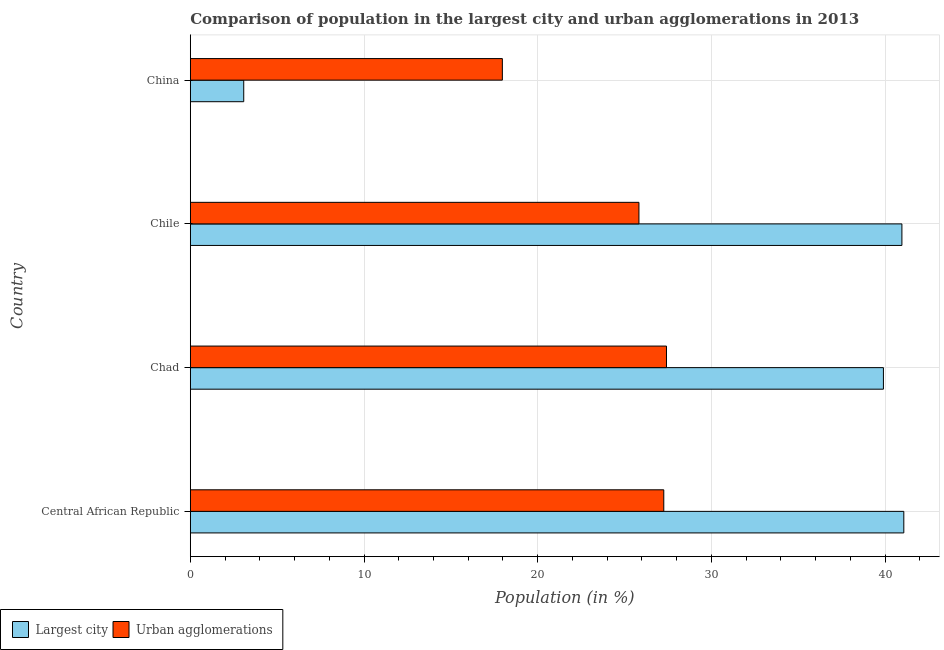Are the number of bars per tick equal to the number of legend labels?
Ensure brevity in your answer.  Yes. Are the number of bars on each tick of the Y-axis equal?
Your response must be concise. Yes. How many bars are there on the 2nd tick from the bottom?
Give a very brief answer. 2. What is the label of the 3rd group of bars from the top?
Make the answer very short. Chad. In how many cases, is the number of bars for a given country not equal to the number of legend labels?
Ensure brevity in your answer.  0. What is the population in urban agglomerations in Chile?
Offer a terse response. 25.83. Across all countries, what is the maximum population in urban agglomerations?
Your answer should be very brief. 27.41. Across all countries, what is the minimum population in the largest city?
Ensure brevity in your answer.  3.08. In which country was the population in urban agglomerations maximum?
Give a very brief answer. Chad. In which country was the population in the largest city minimum?
Ensure brevity in your answer.  China. What is the total population in urban agglomerations in the graph?
Ensure brevity in your answer.  98.46. What is the difference between the population in urban agglomerations in Central African Republic and that in Chad?
Ensure brevity in your answer.  -0.16. What is the difference between the population in urban agglomerations in China and the population in the largest city in Chile?
Ensure brevity in your answer.  -23. What is the average population in the largest city per country?
Provide a succinct answer. 31.25. What is the difference between the population in urban agglomerations and population in the largest city in Central African Republic?
Provide a short and direct response. -13.82. What is the ratio of the population in urban agglomerations in Central African Republic to that in China?
Give a very brief answer. 1.52. Is the population in urban agglomerations in Central African Republic less than that in China?
Provide a short and direct response. No. What is the difference between the highest and the second highest population in the largest city?
Provide a short and direct response. 0.11. In how many countries, is the population in urban agglomerations greater than the average population in urban agglomerations taken over all countries?
Ensure brevity in your answer.  3. What does the 1st bar from the top in Central African Republic represents?
Ensure brevity in your answer.  Urban agglomerations. What does the 2nd bar from the bottom in Chad represents?
Keep it short and to the point. Urban agglomerations. How many bars are there?
Give a very brief answer. 8. Are all the bars in the graph horizontal?
Ensure brevity in your answer.  Yes. Are the values on the major ticks of X-axis written in scientific E-notation?
Give a very brief answer. No. Does the graph contain any zero values?
Your answer should be very brief. No. Does the graph contain grids?
Provide a short and direct response. Yes. How many legend labels are there?
Ensure brevity in your answer.  2. How are the legend labels stacked?
Provide a short and direct response. Horizontal. What is the title of the graph?
Your answer should be compact. Comparison of population in the largest city and urban agglomerations in 2013. What is the label or title of the X-axis?
Your answer should be very brief. Population (in %). What is the label or title of the Y-axis?
Make the answer very short. Country. What is the Population (in %) in Largest city in Central African Republic?
Make the answer very short. 41.07. What is the Population (in %) in Urban agglomerations in Central African Republic?
Provide a short and direct response. 27.26. What is the Population (in %) in Largest city in Chad?
Offer a terse response. 39.9. What is the Population (in %) of Urban agglomerations in Chad?
Offer a terse response. 27.41. What is the Population (in %) of Largest city in Chile?
Make the answer very short. 40.97. What is the Population (in %) of Urban agglomerations in Chile?
Give a very brief answer. 25.83. What is the Population (in %) in Largest city in China?
Make the answer very short. 3.08. What is the Population (in %) in Urban agglomerations in China?
Your answer should be very brief. 17.96. Across all countries, what is the maximum Population (in %) of Largest city?
Make the answer very short. 41.07. Across all countries, what is the maximum Population (in %) in Urban agglomerations?
Give a very brief answer. 27.41. Across all countries, what is the minimum Population (in %) in Largest city?
Your answer should be very brief. 3.08. Across all countries, what is the minimum Population (in %) of Urban agglomerations?
Offer a very short reply. 17.96. What is the total Population (in %) of Largest city in the graph?
Provide a short and direct response. 125.02. What is the total Population (in %) in Urban agglomerations in the graph?
Your answer should be compact. 98.46. What is the difference between the Population (in %) in Largest city in Central African Republic and that in Chad?
Ensure brevity in your answer.  1.17. What is the difference between the Population (in %) in Urban agglomerations in Central African Republic and that in Chad?
Offer a very short reply. -0.16. What is the difference between the Population (in %) in Largest city in Central African Republic and that in Chile?
Provide a short and direct response. 0.11. What is the difference between the Population (in %) in Urban agglomerations in Central African Republic and that in Chile?
Your answer should be very brief. 1.43. What is the difference between the Population (in %) in Largest city in Central African Republic and that in China?
Give a very brief answer. 38. What is the difference between the Population (in %) in Urban agglomerations in Central African Republic and that in China?
Provide a short and direct response. 9.29. What is the difference between the Population (in %) of Largest city in Chad and that in Chile?
Give a very brief answer. -1.06. What is the difference between the Population (in %) in Urban agglomerations in Chad and that in Chile?
Provide a succinct answer. 1.59. What is the difference between the Population (in %) of Largest city in Chad and that in China?
Offer a very short reply. 36.82. What is the difference between the Population (in %) of Urban agglomerations in Chad and that in China?
Your answer should be compact. 9.45. What is the difference between the Population (in %) of Largest city in Chile and that in China?
Provide a short and direct response. 37.89. What is the difference between the Population (in %) of Urban agglomerations in Chile and that in China?
Your answer should be very brief. 7.86. What is the difference between the Population (in %) in Largest city in Central African Republic and the Population (in %) in Urban agglomerations in Chad?
Give a very brief answer. 13.66. What is the difference between the Population (in %) in Largest city in Central African Republic and the Population (in %) in Urban agglomerations in Chile?
Provide a short and direct response. 15.25. What is the difference between the Population (in %) of Largest city in Central African Republic and the Population (in %) of Urban agglomerations in China?
Offer a terse response. 23.11. What is the difference between the Population (in %) in Largest city in Chad and the Population (in %) in Urban agglomerations in Chile?
Give a very brief answer. 14.07. What is the difference between the Population (in %) of Largest city in Chad and the Population (in %) of Urban agglomerations in China?
Your answer should be very brief. 21.94. What is the difference between the Population (in %) in Largest city in Chile and the Population (in %) in Urban agglomerations in China?
Provide a succinct answer. 23. What is the average Population (in %) in Largest city per country?
Ensure brevity in your answer.  31.25. What is the average Population (in %) of Urban agglomerations per country?
Give a very brief answer. 24.62. What is the difference between the Population (in %) of Largest city and Population (in %) of Urban agglomerations in Central African Republic?
Ensure brevity in your answer.  13.82. What is the difference between the Population (in %) in Largest city and Population (in %) in Urban agglomerations in Chad?
Give a very brief answer. 12.49. What is the difference between the Population (in %) in Largest city and Population (in %) in Urban agglomerations in Chile?
Your answer should be very brief. 15.14. What is the difference between the Population (in %) of Largest city and Population (in %) of Urban agglomerations in China?
Keep it short and to the point. -14.89. What is the ratio of the Population (in %) of Largest city in Central African Republic to that in Chad?
Provide a succinct answer. 1.03. What is the ratio of the Population (in %) of Urban agglomerations in Central African Republic to that in Chad?
Offer a terse response. 0.99. What is the ratio of the Population (in %) of Urban agglomerations in Central African Republic to that in Chile?
Your response must be concise. 1.06. What is the ratio of the Population (in %) of Largest city in Central African Republic to that in China?
Your answer should be compact. 13.35. What is the ratio of the Population (in %) in Urban agglomerations in Central African Republic to that in China?
Offer a terse response. 1.52. What is the ratio of the Population (in %) in Largest city in Chad to that in Chile?
Offer a terse response. 0.97. What is the ratio of the Population (in %) of Urban agglomerations in Chad to that in Chile?
Offer a very short reply. 1.06. What is the ratio of the Population (in %) in Largest city in Chad to that in China?
Ensure brevity in your answer.  12.97. What is the ratio of the Population (in %) in Urban agglomerations in Chad to that in China?
Offer a terse response. 1.53. What is the ratio of the Population (in %) in Largest city in Chile to that in China?
Offer a very short reply. 13.32. What is the ratio of the Population (in %) of Urban agglomerations in Chile to that in China?
Your answer should be compact. 1.44. What is the difference between the highest and the second highest Population (in %) of Largest city?
Make the answer very short. 0.11. What is the difference between the highest and the second highest Population (in %) of Urban agglomerations?
Keep it short and to the point. 0.16. What is the difference between the highest and the lowest Population (in %) in Largest city?
Make the answer very short. 38. What is the difference between the highest and the lowest Population (in %) in Urban agglomerations?
Give a very brief answer. 9.45. 